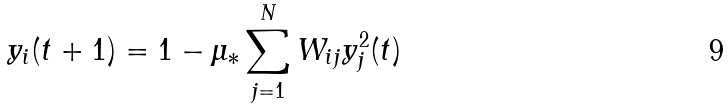Convert formula to latex. <formula><loc_0><loc_0><loc_500><loc_500>y _ { i } ( t + 1 ) = 1 - \mu _ { * } \sum _ { j = 1 } ^ { N } W _ { i j } y _ { j } ^ { 2 } ( t )</formula> 